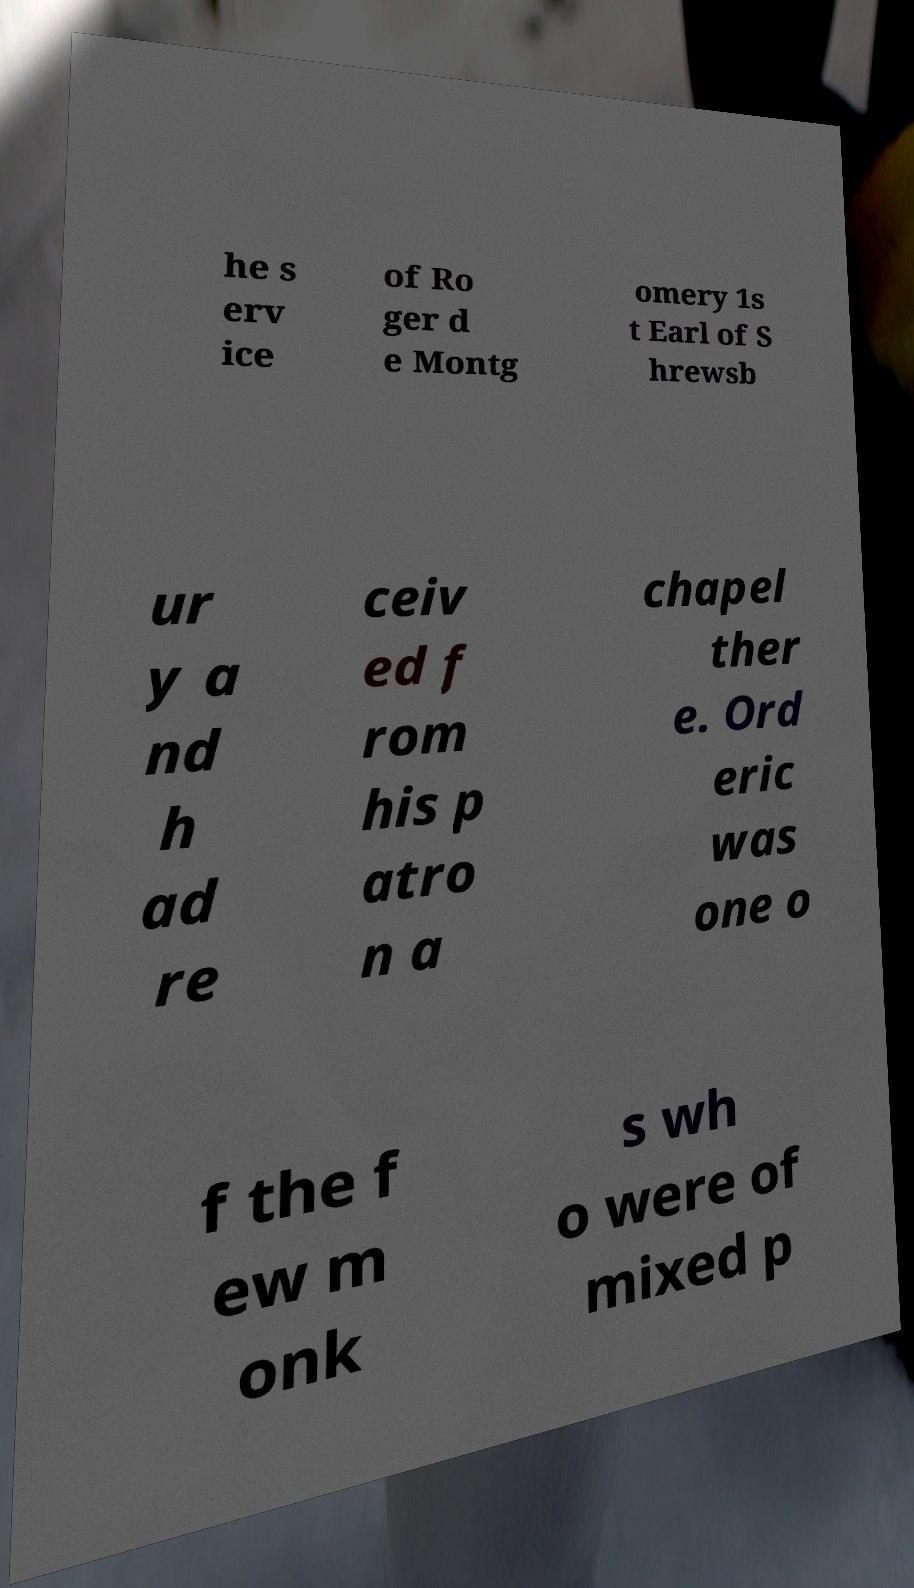Please read and relay the text visible in this image. What does it say? he s erv ice of Ro ger d e Montg omery 1s t Earl of S hrewsb ur y a nd h ad re ceiv ed f rom his p atro n a chapel ther e. Ord eric was one o f the f ew m onk s wh o were of mixed p 